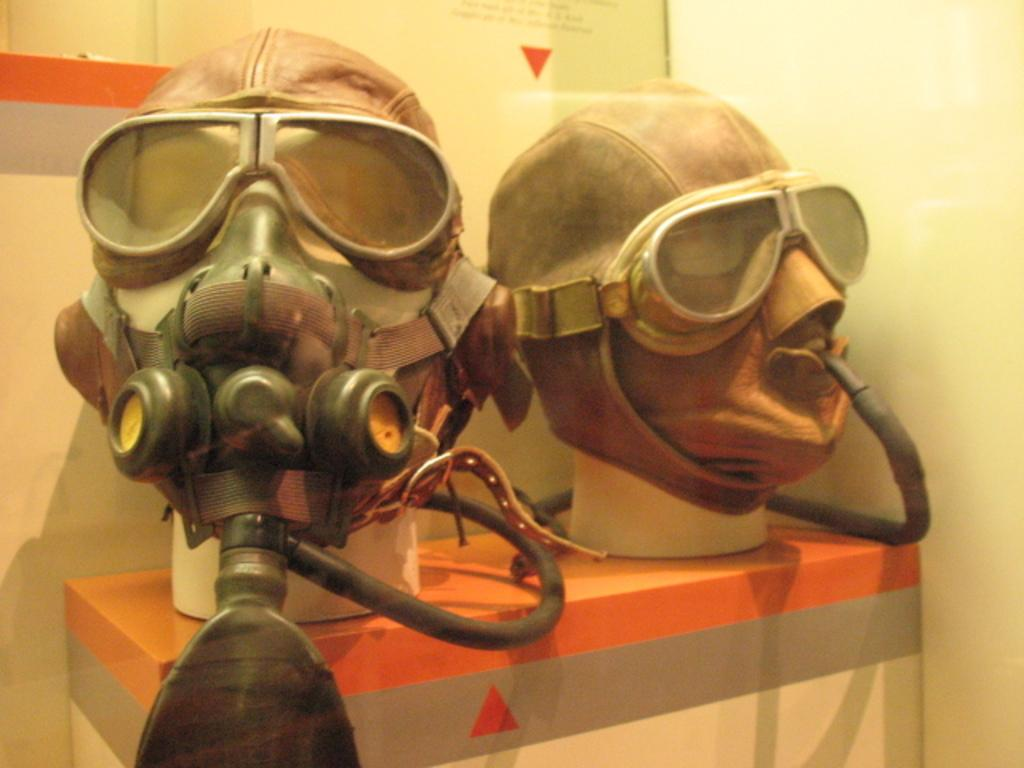What protective equipment is visible in the image? There is a gas mask with a cylinder in the image. Where is the gas mask and cylinder located? The gas mask and cylinder are on a table. What can be seen in the background of the image? There is a wall in the background of the image. What type of oven is visible in the image? There is no oven present in the image. How many ants can be seen crawling on the gas mask in the image? There are no ants visible in the image. 